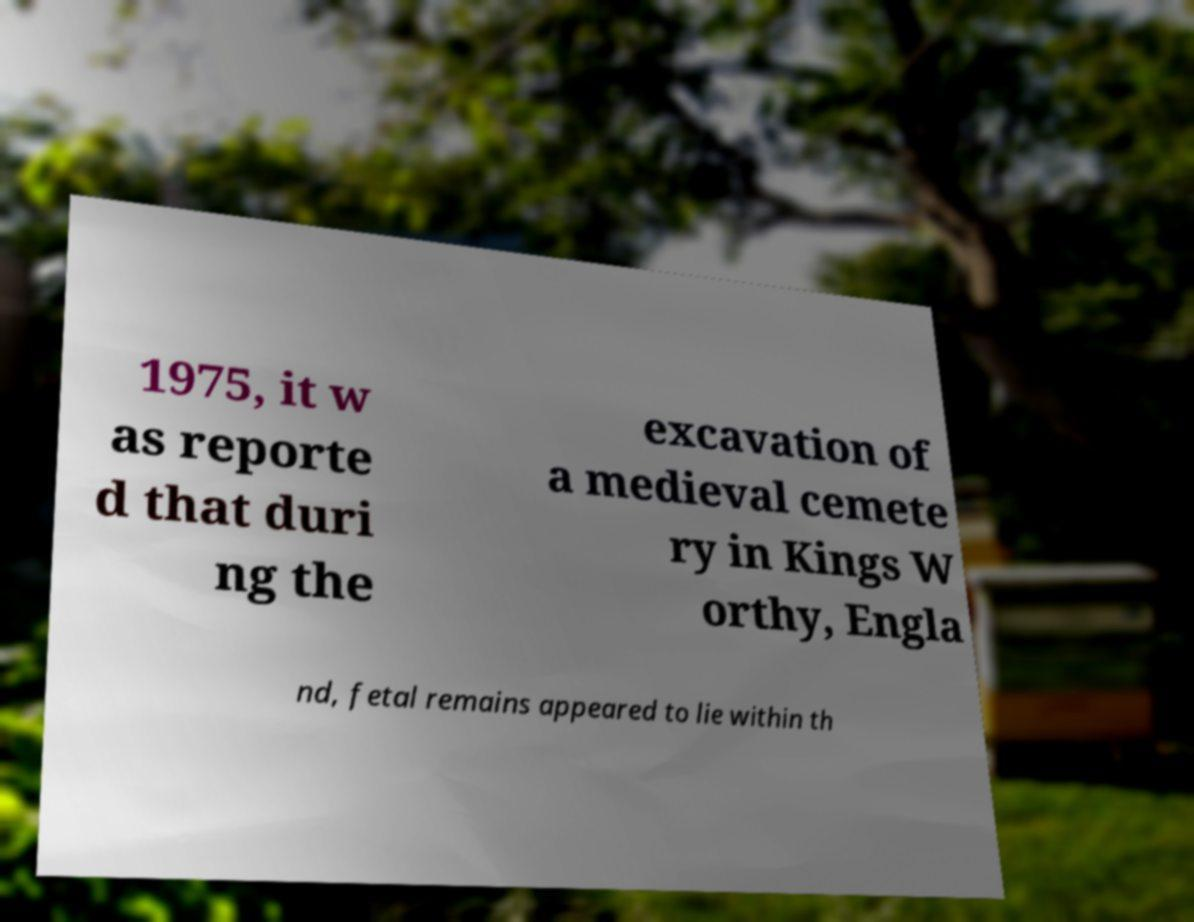Please read and relay the text visible in this image. What does it say? 1975, it w as reporte d that duri ng the excavation of a medieval cemete ry in Kings W orthy, Engla nd, fetal remains appeared to lie within th 